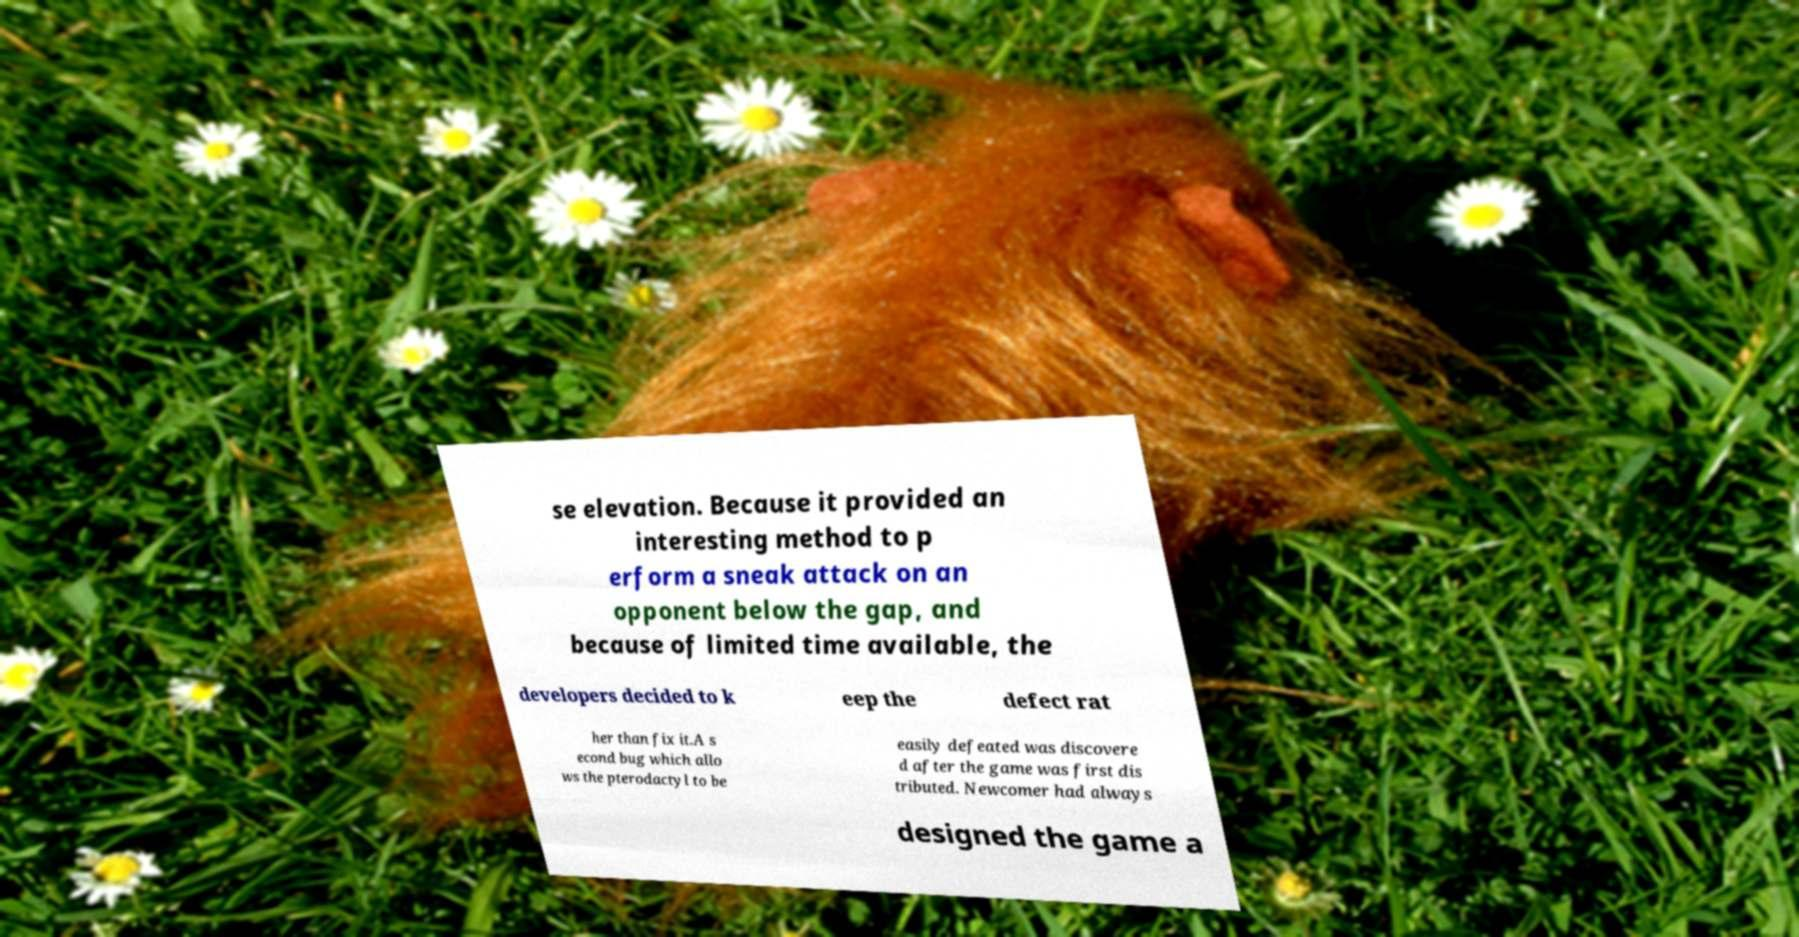Can you accurately transcribe the text from the provided image for me? se elevation. Because it provided an interesting method to p erform a sneak attack on an opponent below the gap, and because of limited time available, the developers decided to k eep the defect rat her than fix it.A s econd bug which allo ws the pterodactyl to be easily defeated was discovere d after the game was first dis tributed. Newcomer had always designed the game a 